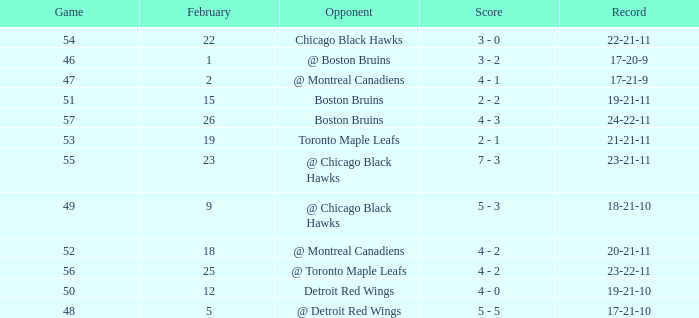What was the game score of the match held post-february 18 against the chicago black hawks, before game 56? 3 - 0. 